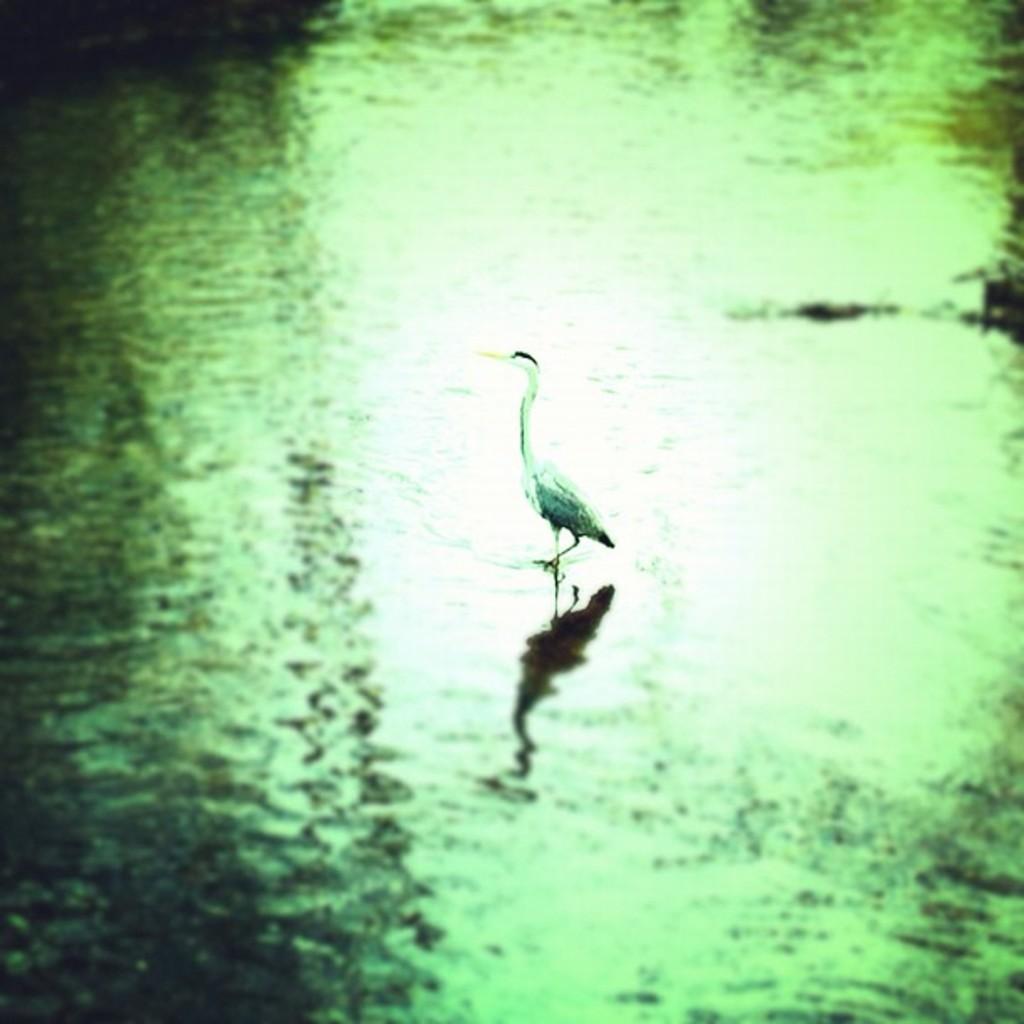Describe this image in one or two sentences. In this image, we can see a crane walking in the water. 